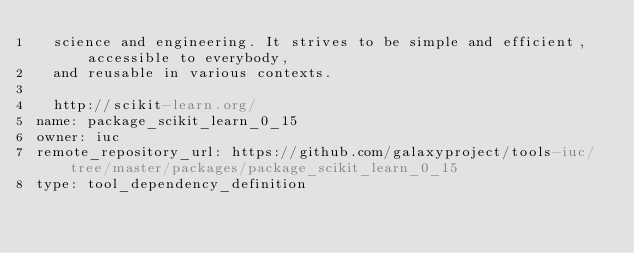<code> <loc_0><loc_0><loc_500><loc_500><_YAML_>  science and engineering. It strives to be simple and efficient, accessible to everybody,
  and reusable in various contexts.

  http://scikit-learn.org/
name: package_scikit_learn_0_15
owner: iuc
remote_repository_url: https://github.com/galaxyproject/tools-iuc/tree/master/packages/package_scikit_learn_0_15
type: tool_dependency_definition
</code> 